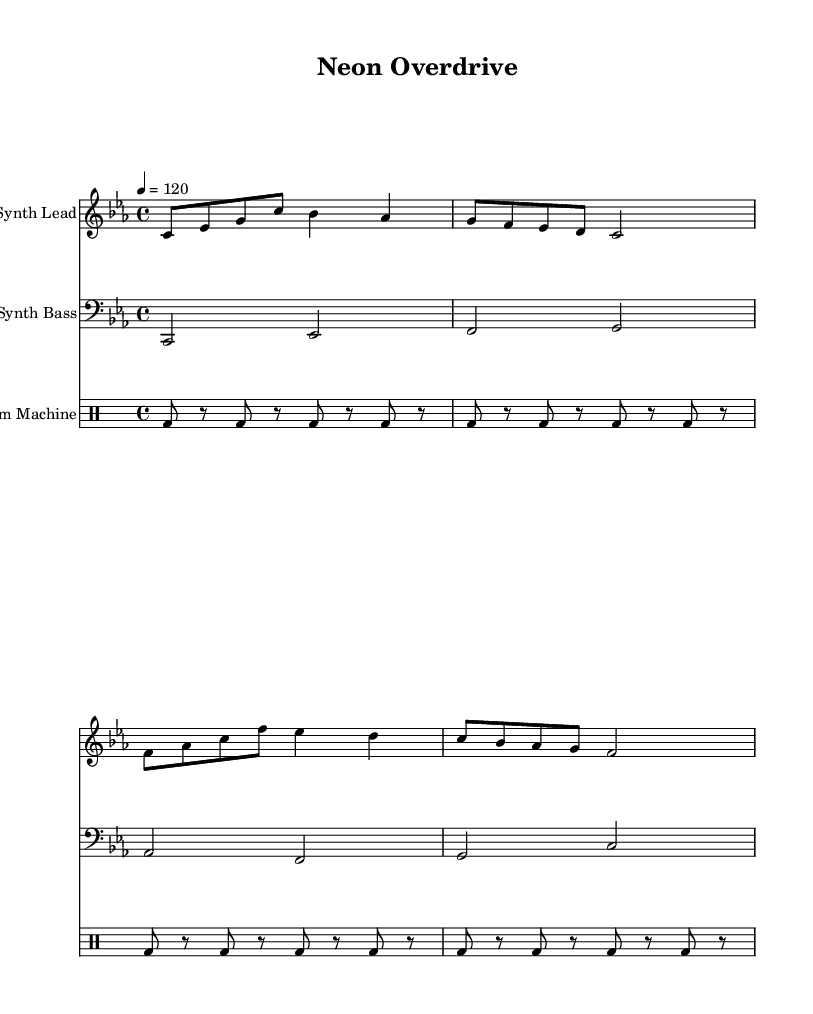What is the key signature of this music? The key signature is C minor, which has three flats (B♭, E♭, A♭). This is indicated at the beginning of the staff where the flats are notated.
Answer: C minor What is the time signature of this music? The time signature is 4/4, which means there are four beats in each measure with a quarter note getting one beat. This is clearly indicated at the beginning of the score.
Answer: 4/4 What tempo marking is used in this music? The tempo marking is 120 bpm, indicated by "4 = 120" in the score. This means the quarter note should be played at 120 beats per minute.
Answer: 120 How many measures are in the synth lead section? There are 4 measures in the synth lead section, as evidenced by the vertical lines (bar lines) that separate the musical phrases.
Answer: 4 Which instruments are used in this composition? The composition includes three instruments: Synth Lead, Synth Bass, and Drum Machine, noted at the beginning of each staff.
Answer: Synth Lead, Synth Bass, Drum Machine What type of rhythm is primarily used in the drum machine part? The rhythm used in the drum machine part consists mainly of bass drum hits, played on the eighth notes of each measure, creating a driving, repetitive rhythm typical of synthwave music.
Answer: Eighth notes Which musical style does this piece represent? This piece represents the Synthwave genre, characterized by its retro sound and incorporation of 80s aesthetics, often reminiscent of car culture and modern tech themes.
Answer: Synthwave 